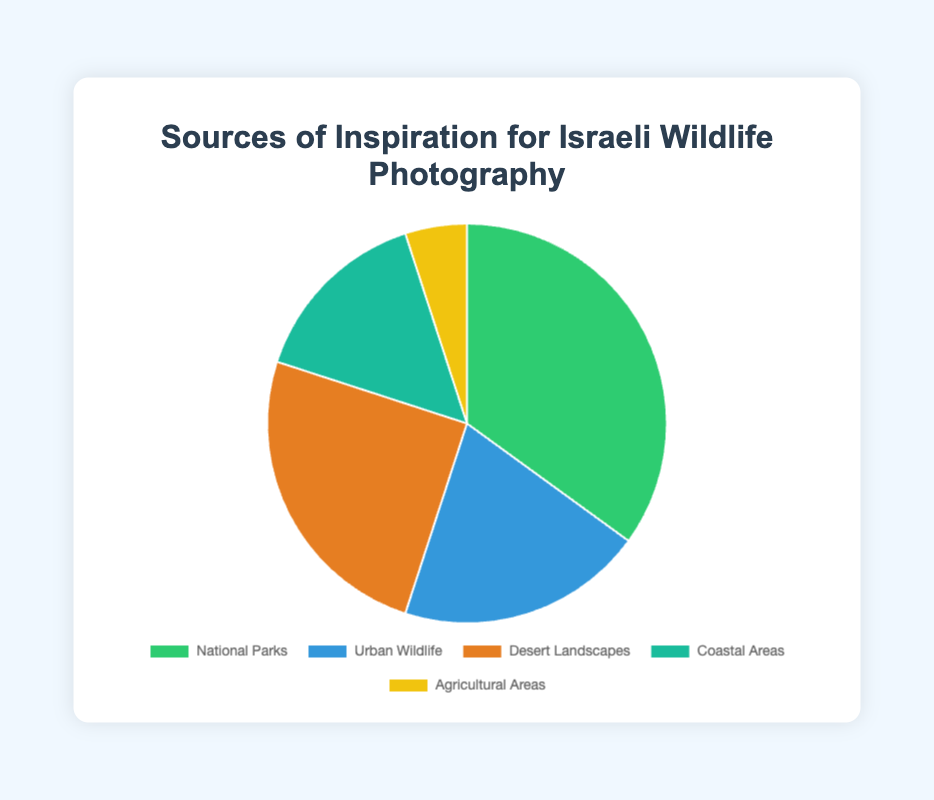What's the most common source of inspiration for Israeli wildlife photography? The pie chart shows that "National Parks" has the largest percentage at 35%, making it the most common source of inspiration.
Answer: National Parks Which source of inspiration has the smallest percentage? By looking at the pie chart, "Agricultural Areas" has the smallest percentage at 5%.
Answer: Agricultural Areas By how much does the percentage of "Urban Wildlife" exceed that of "Coastal Areas"? The percentage for "Urban Wildlife" is 20%, and for "Coastal Areas" is 15%. The difference is 20% - 15% = 5%.
Answer: 5% What percentage of inspiration sources come from areas other than National Parks? The percentages for sources other than National Parks are summed up: Urban Wildlife (20%) + Desert Landscapes (25%) + Coastal Areas (15%) + Agricultural Areas (5%) = 65%.
Answer: 65% What's the combined percentage of inspiration coming from "Coastal Areas" and "Desert Landscapes"? The percentage for "Coastal Areas" is 15%, and for "Desert Landscapes" is 25%. The combined percentage is 15% + 25% = 40%.
Answer: 40% Which sources of inspiration combined make up more than half of the total percentage? National Parks (35%) and Desert Landscapes (25%) combined make up 60%, which is more than half of the total (50%).
Answer: National Parks and Desert Landscapes Is the percentage of "Urban Wildlife" less than the combined percentage of "Coastal Areas" and "Agricultural Areas"? The combined percentage of Coastal Areas (15%) and Agricultural Areas (5%) is 20%, which is equal to the percentage of Urban Wildlife (20%).
Answer: No Which source of inspiration is represented by a green color in the pie chart? By observing the colors in the pie chart and associating them with the labels, "National Parks" is represented by green.
Answer: National Parks 